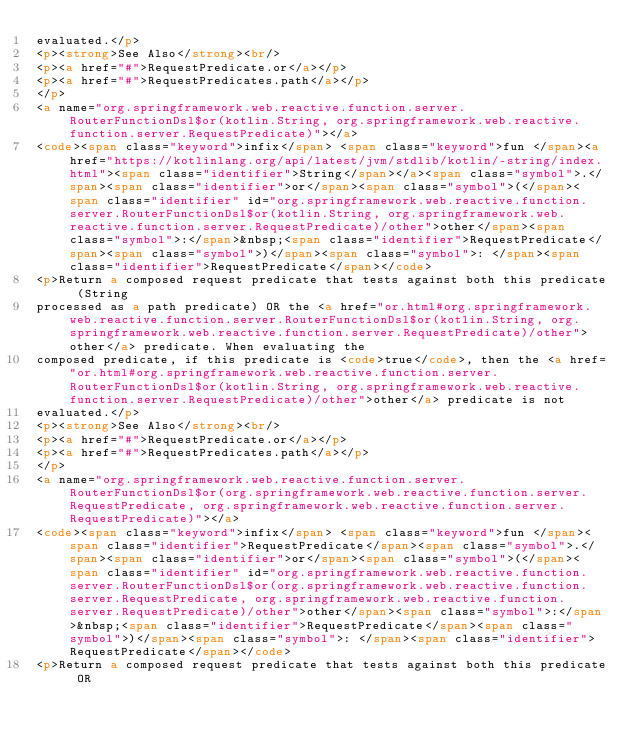<code> <loc_0><loc_0><loc_500><loc_500><_HTML_>evaluated.</p>
<p><strong>See Also</strong><br/>
<p><a href="#">RequestPredicate.or</a></p>
<p><a href="#">RequestPredicates.path</a></p>
</p>
<a name="org.springframework.web.reactive.function.server.RouterFunctionDsl$or(kotlin.String, org.springframework.web.reactive.function.server.RequestPredicate)"></a>
<code><span class="keyword">infix</span> <span class="keyword">fun </span><a href="https://kotlinlang.org/api/latest/jvm/stdlib/kotlin/-string/index.html"><span class="identifier">String</span></a><span class="symbol">.</span><span class="identifier">or</span><span class="symbol">(</span><span class="identifier" id="org.springframework.web.reactive.function.server.RouterFunctionDsl$or(kotlin.String, org.springframework.web.reactive.function.server.RequestPredicate)/other">other</span><span class="symbol">:</span>&nbsp;<span class="identifier">RequestPredicate</span><span class="symbol">)</span><span class="symbol">: </span><span class="identifier">RequestPredicate</span></code>
<p>Return a composed request predicate that tests against both this predicate (String
processed as a path predicate) OR the <a href="or.html#org.springframework.web.reactive.function.server.RouterFunctionDsl$or(kotlin.String, org.springframework.web.reactive.function.server.RequestPredicate)/other">other</a> predicate. When evaluating the
composed predicate, if this predicate is <code>true</code>, then the <a href="or.html#org.springframework.web.reactive.function.server.RouterFunctionDsl$or(kotlin.String, org.springframework.web.reactive.function.server.RequestPredicate)/other">other</a> predicate is not
evaluated.</p>
<p><strong>See Also</strong><br/>
<p><a href="#">RequestPredicate.or</a></p>
<p><a href="#">RequestPredicates.path</a></p>
</p>
<a name="org.springframework.web.reactive.function.server.RouterFunctionDsl$or(org.springframework.web.reactive.function.server.RequestPredicate, org.springframework.web.reactive.function.server.RequestPredicate)"></a>
<code><span class="keyword">infix</span> <span class="keyword">fun </span><span class="identifier">RequestPredicate</span><span class="symbol">.</span><span class="identifier">or</span><span class="symbol">(</span><span class="identifier" id="org.springframework.web.reactive.function.server.RouterFunctionDsl$or(org.springframework.web.reactive.function.server.RequestPredicate, org.springframework.web.reactive.function.server.RequestPredicate)/other">other</span><span class="symbol">:</span>&nbsp;<span class="identifier">RequestPredicate</span><span class="symbol">)</span><span class="symbol">: </span><span class="identifier">RequestPredicate</span></code>
<p>Return a composed request predicate that tests against both this predicate OR</code> 